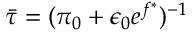<formula> <loc_0><loc_0><loc_500><loc_500>\bar { \tau } = ( \pi _ { 0 } + \epsilon _ { 0 } e ^ { f ^ { \ast } } ) ^ { - 1 }</formula> 